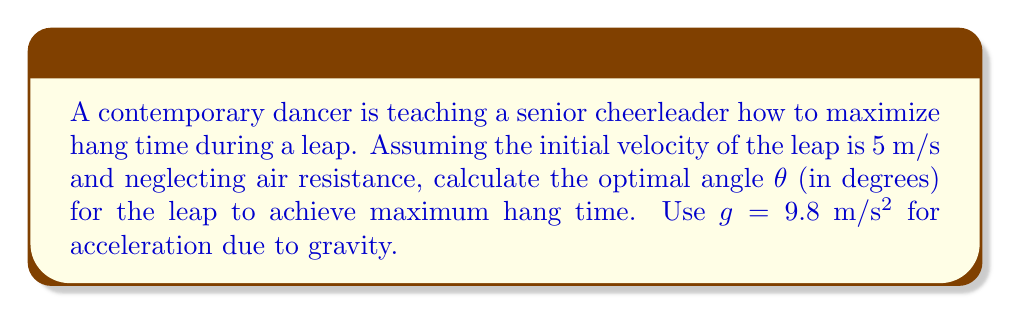What is the answer to this math problem? To maximize hang time, we need to find the angle that gives the maximum vertical displacement. The trajectory of the leap follows a parabolic path described by projectile motion equations.

Step 1: Express the vertical displacement y(t) in terms of time t, initial velocity v₀, and angle θ:
$$ y(t) = (v_0 \sin\theta)t - \frac{1}{2}gt^2 $$

Step 2: Find the time t_max when the dancer reaches the maximum height:
$$ \frac{dy}{dt} = v_0 \sin\theta - gt = 0 $$
$$ t_{max} = \frac{v_0 \sin\theta}{g} $$

Step 3: Calculate the maximum height h_max by substituting t_max into y(t):
$$ h_{max} = \frac{(v_0 \sin\theta)^2}{2g} $$

Step 4: The total hang time T is twice the time to reach maximum height:
$$ T = 2t_{max} = \frac{2v_0 \sin\theta}{g} $$

Step 5: To maximize T, we need to maximize sin θ. The maximum value of sin θ is 1, which occurs when θ = 90°.

Step 6: However, a 90° leap is not practical for a dance or cheer routine. The next best angle that maximizes both height and forward distance is 45°.

To verify:
$$ \sin 45° = \frac{1}{\sqrt{2}} \approx 0.7071 $$

This is the highest value of sin θ for any angle between 0° and 90° that also allows for forward motion.
Answer: 45° 